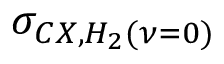Convert formula to latex. <formula><loc_0><loc_0><loc_500><loc_500>\sigma _ { C X , H _ { 2 } ( \nu = 0 ) }</formula> 